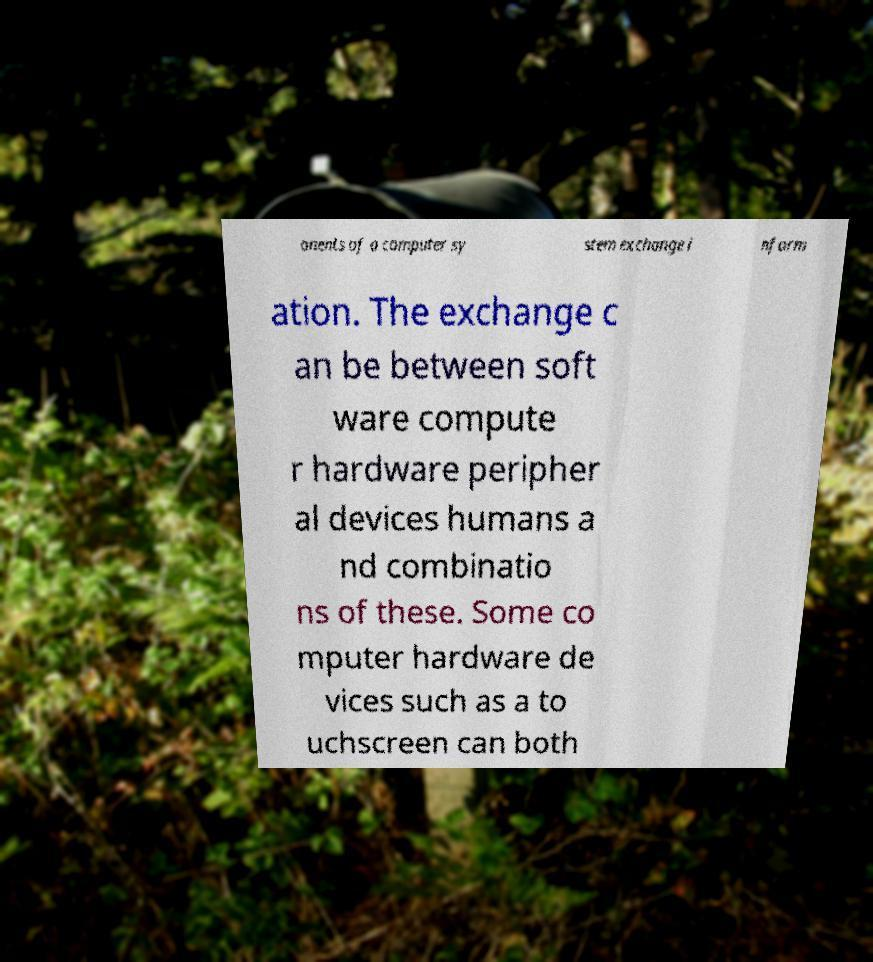What messages or text are displayed in this image? I need them in a readable, typed format. onents of a computer sy stem exchange i nform ation. The exchange c an be between soft ware compute r hardware peripher al devices humans a nd combinatio ns of these. Some co mputer hardware de vices such as a to uchscreen can both 